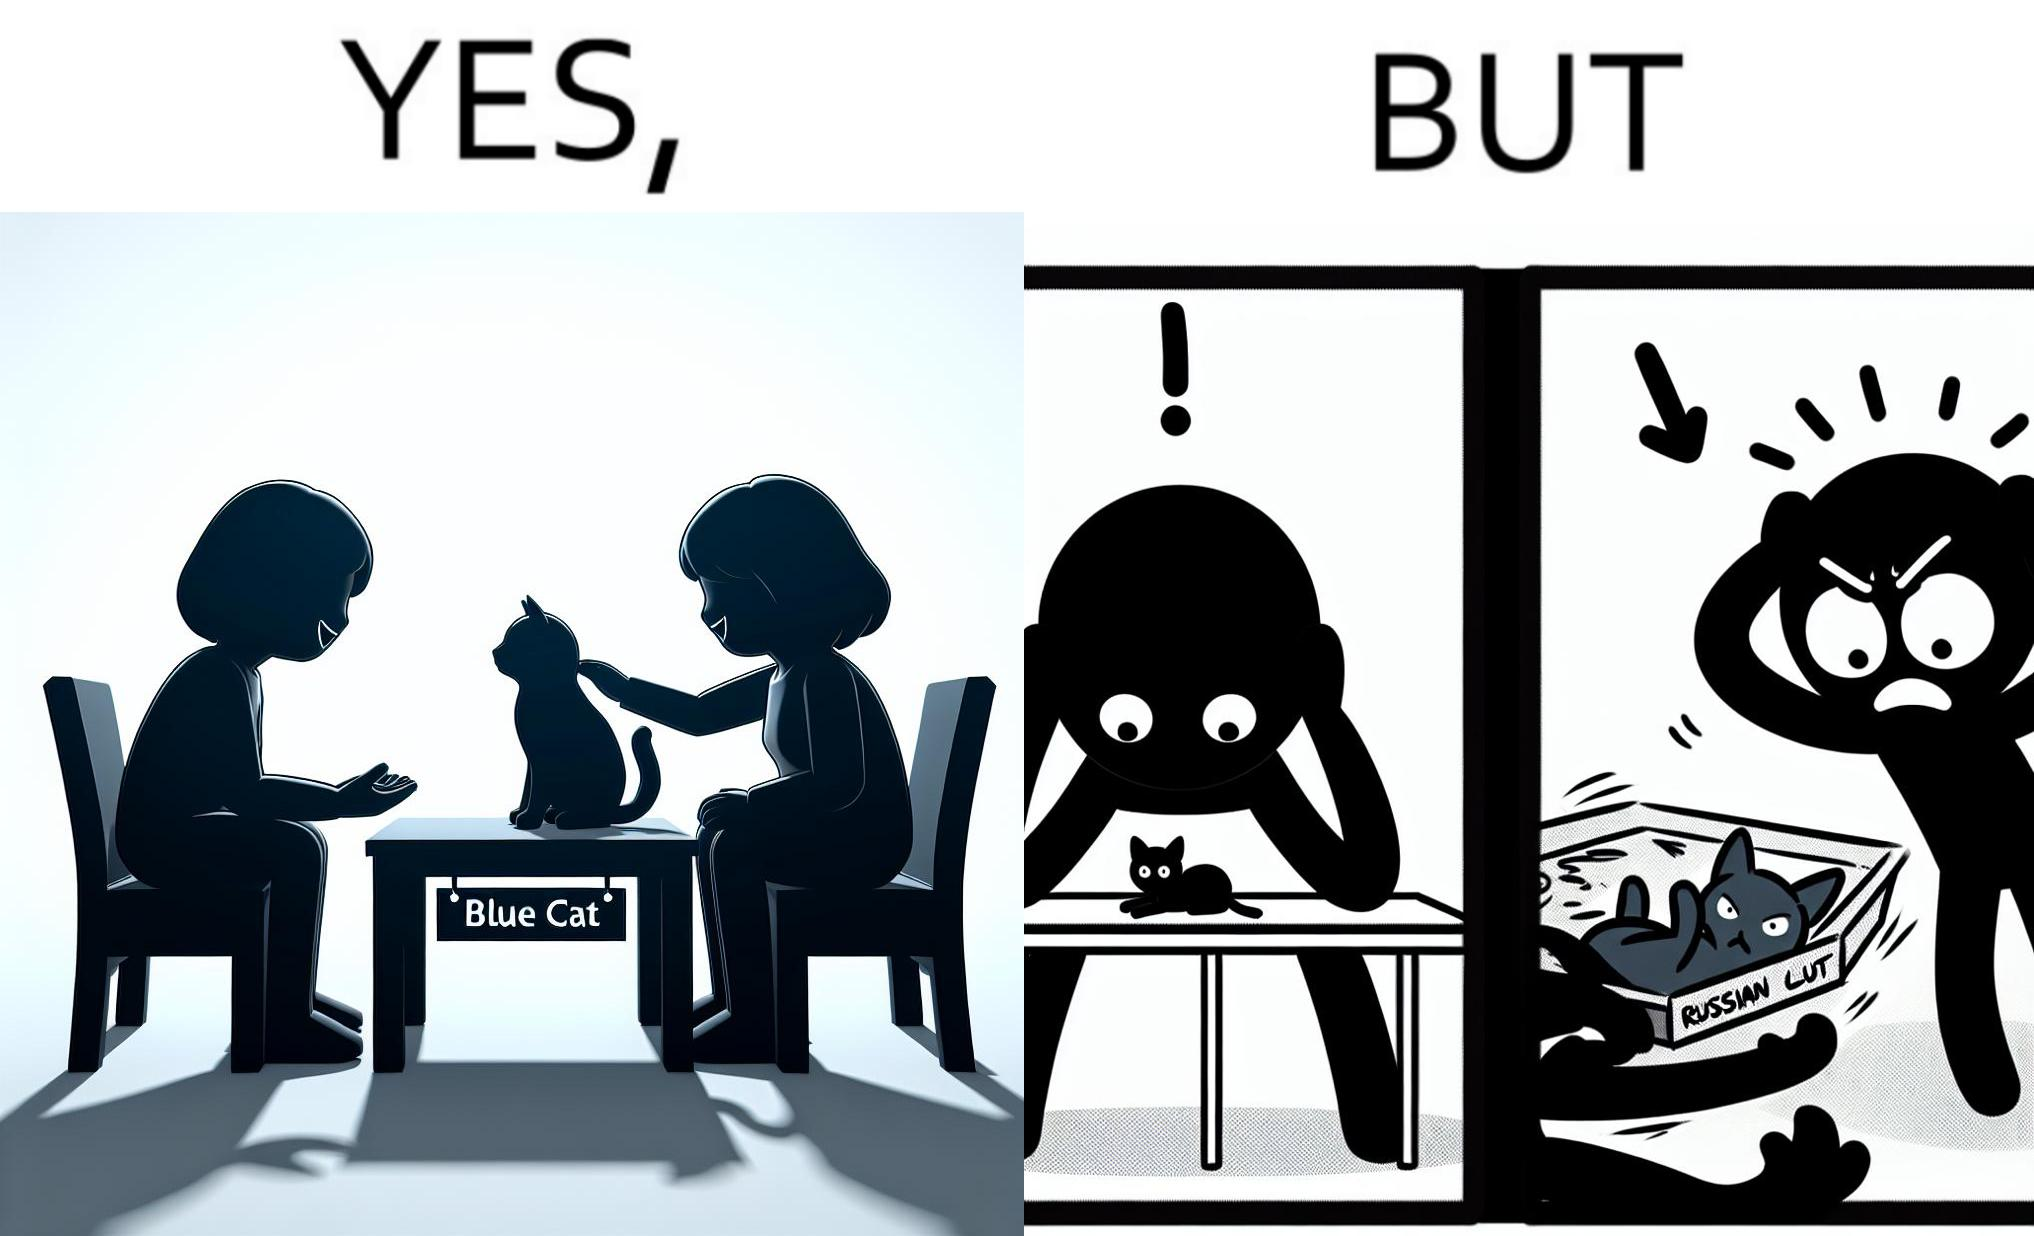Describe the satirical element in this image. The image is confusing, as initially, when the label reads "Blue Cat", the people are happy and are petting tha cat, but as soon as one of them realizes that the entire text reads "Russian Blue Cat", they seem to worried, and one of them throws away the cat. For some reason, the word "Russian" is a trigger word for them. 